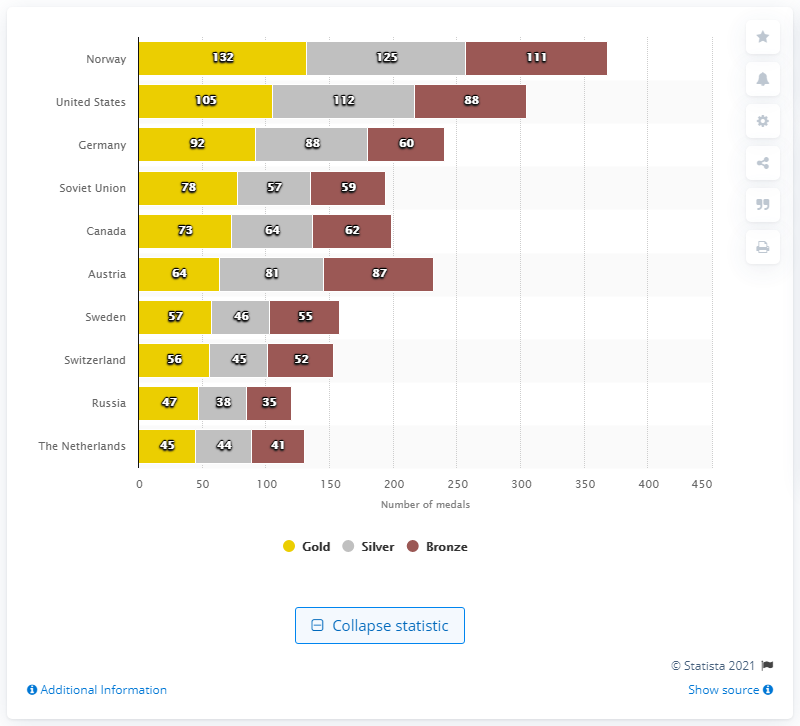Highlight a few significant elements in this photo. Norway has won a total of 132 gold medals at the Winter Olympics. The values of the yellow bar are sorted from top to bottom. Norway has won 111 bronze medals at the Winter Olympics. Norway has won a total of 111 bronze medals at the Winter Olympics. Norway has won a total of 132 gold medals at the Winter Olympics. 